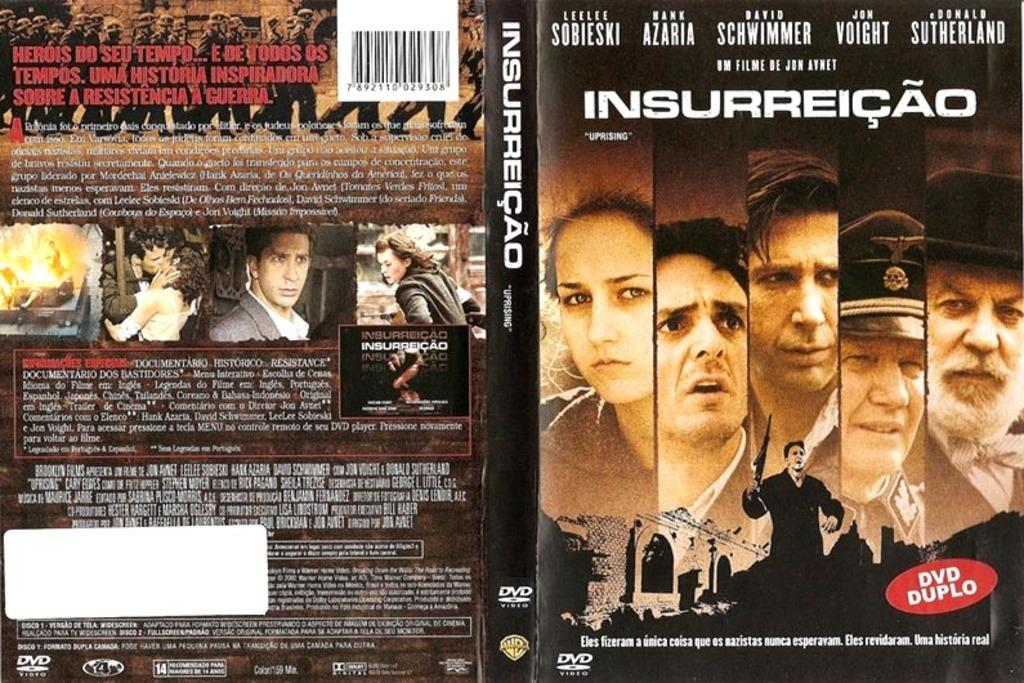What is present in the image that contains both text and images? There is a poster in the image that contains text and images of persons. Can you describe the content of the poster? The poster contains text and images of persons. What statement does the team make in the image? There is no team present in the image, and therefore no statement can be attributed to a team. 